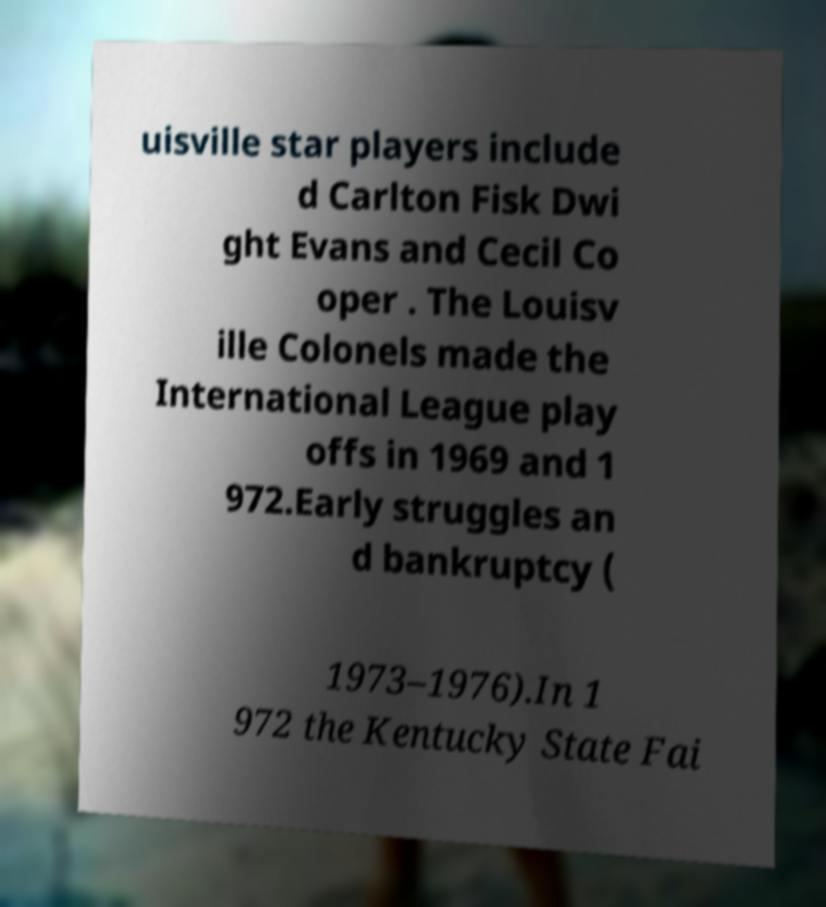Please identify and transcribe the text found in this image. uisville star players include d Carlton Fisk Dwi ght Evans and Cecil Co oper . The Louisv ille Colonels made the International League play offs in 1969 and 1 972.Early struggles an d bankruptcy ( 1973–1976).In 1 972 the Kentucky State Fai 